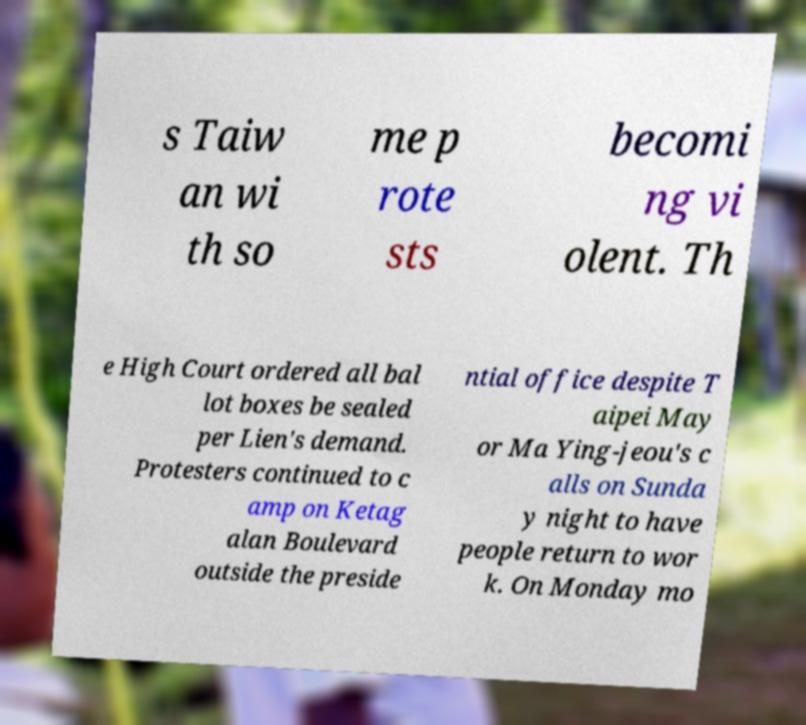Can you read and provide the text displayed in the image?This photo seems to have some interesting text. Can you extract and type it out for me? s Taiw an wi th so me p rote sts becomi ng vi olent. Th e High Court ordered all bal lot boxes be sealed per Lien's demand. Protesters continued to c amp on Ketag alan Boulevard outside the preside ntial office despite T aipei May or Ma Ying-jeou's c alls on Sunda y night to have people return to wor k. On Monday mo 